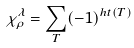Convert formula to latex. <formula><loc_0><loc_0><loc_500><loc_500>\chi _ { \rho } ^ { \lambda } = \sum _ { T } ( - 1 ) ^ { h t ( T ) }</formula> 